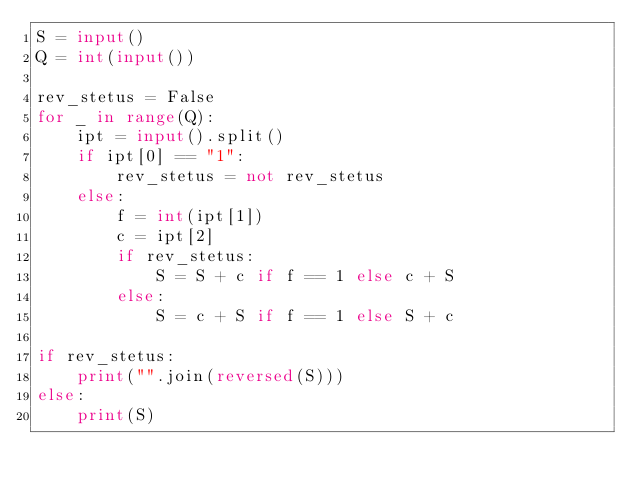Convert code to text. <code><loc_0><loc_0><loc_500><loc_500><_Python_>S = input()
Q = int(input())

rev_stetus = False
for _ in range(Q):
    ipt = input().split()
    if ipt[0] == "1":
        rev_stetus = not rev_stetus
    else:
        f = int(ipt[1])
        c = ipt[2]
        if rev_stetus:
            S = S + c if f == 1 else c + S
        else:
            S = c + S if f == 1 else S + c

if rev_stetus:
    print("".join(reversed(S)))
else:
    print(S)</code> 